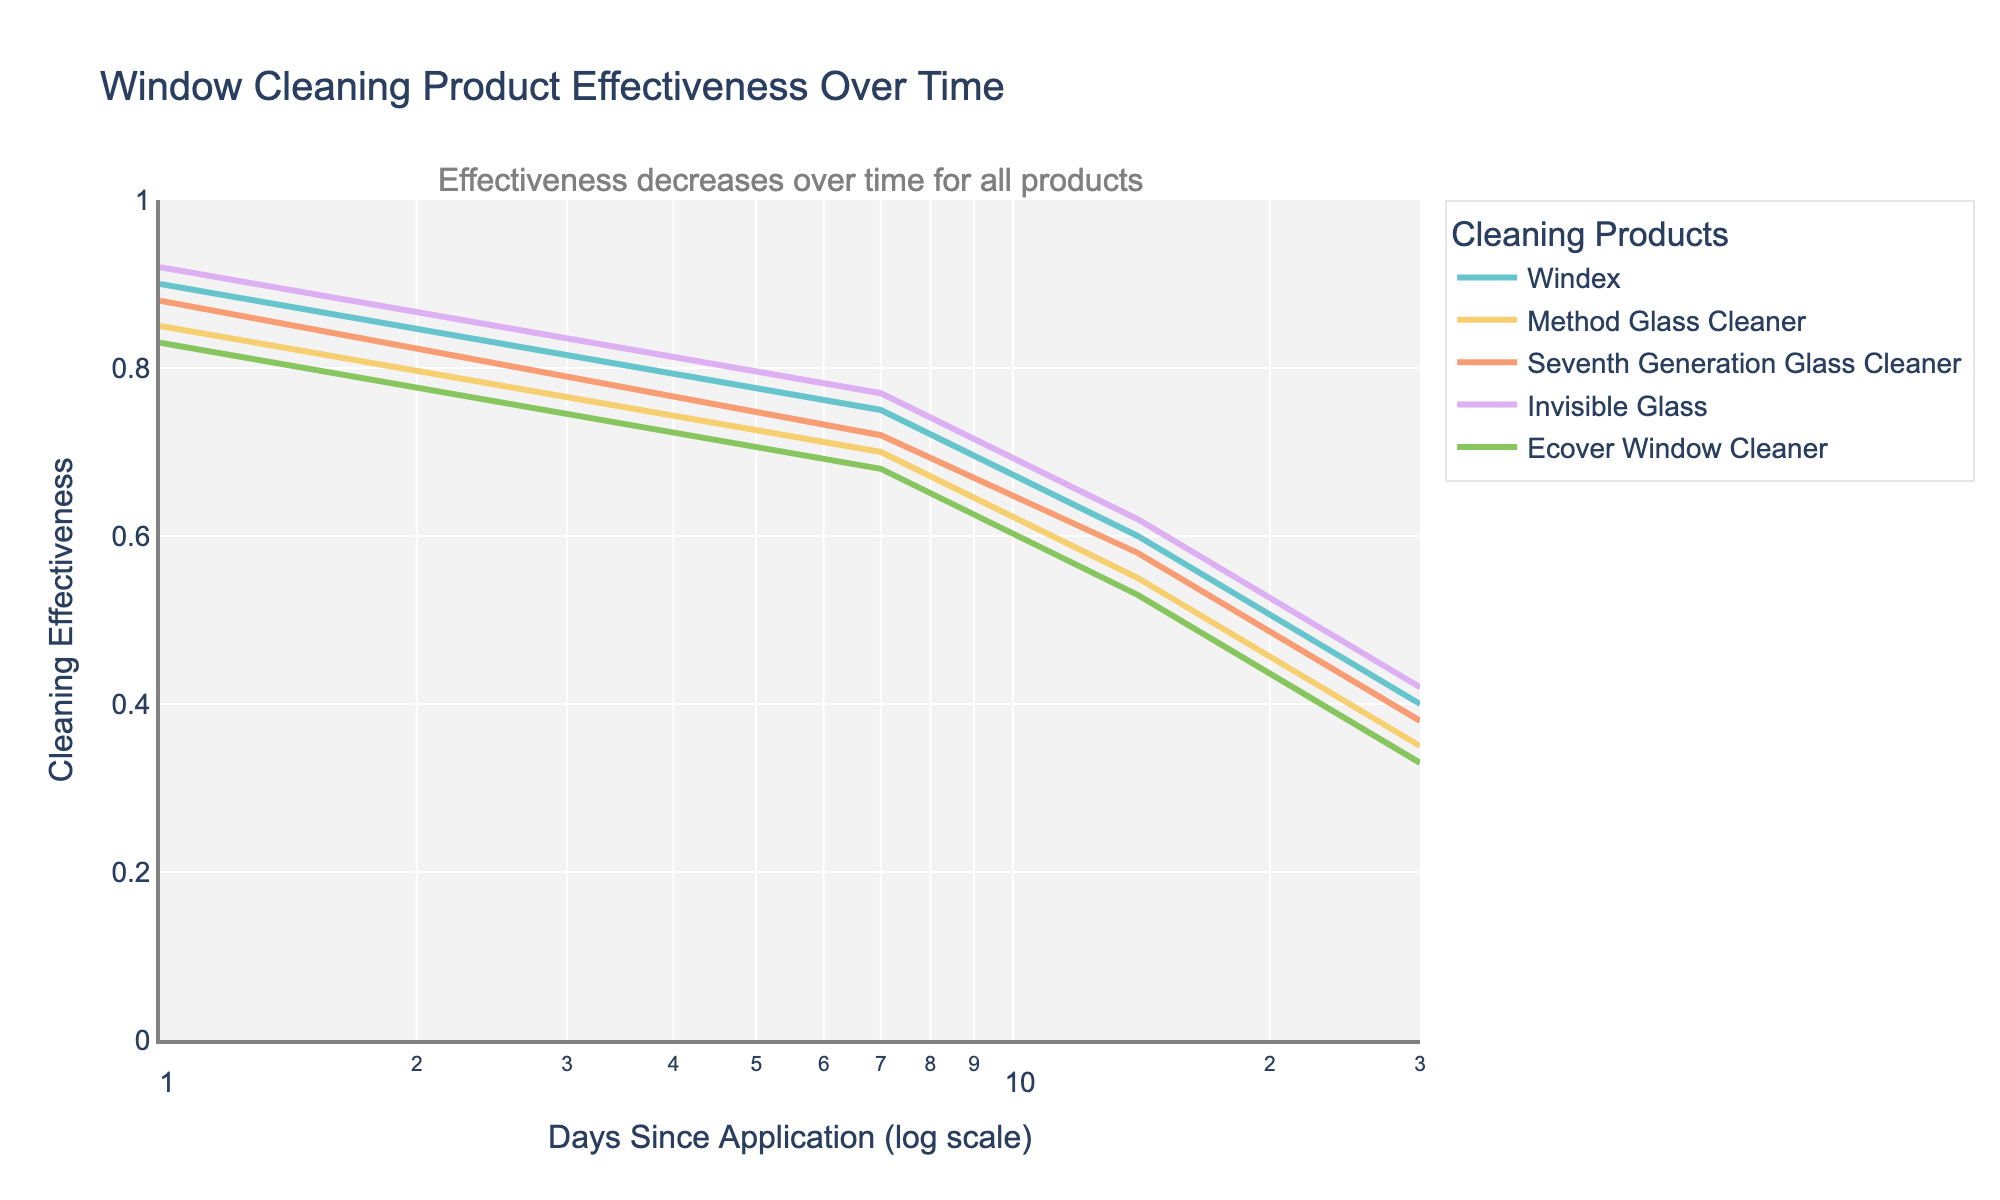Which product starts with the highest effectiveness on day 1? The plot shows that on day 1, Invisible Glass has the highest effectiveness with a value of 0.92. This can be observed by comparing the y-values of all lines at the first point on the x-axis.
Answer: Invisible Glass Which product has the lowest effectiveness after 30 days? On the 30th day, Ecover Window Cleaner has the lowest effectiveness with a value of 0.33. This is determined by looking at the y-values at 30 days for all products and finding the smallest.
Answer: Ecover Window Cleaner What is the overall trend in effectiveness for all products over time? The annotation on the plot confirms that the overall trend is a decrease in effectiveness for all products over time. This can also be observed by the downward slope of all lines on the graph.
Answer: Decreases Which two products have the closest effectiveness on day 14? On day 14, Windex has an effectiveness of 0.6, and Invisible Glass has an effectiveness of 0.62. These values are the closest when comparing all products at the 14-day mark.
Answer: Windex and Invisible Glass How does the effectiveness of Method Glass Cleaner compare to Seventh Generation Glass Cleaner at 7 days? At 7 days, Method Glass Cleaner has an effectiveness of 0.7, while Seventh Generation Glass Cleaner has an effectiveness of 0.72. Seventh Generation Glass Cleaner is slightly more effective than Method Glass Cleaner at this time point.
Answer: Seventh Generation Glass Cleaner is slightly more effective Which product shows the steepest decline in effectiveness from day 1 to day 30? To determine this, we need to calculate the difference in effectiveness from day 1 to day 30 for each product. Ecover Window Cleaner decreases from 0.83 to 0.33, a drop of 0.5. This is the steepest decline among all products.
Answer: Ecover Window Cleaner What is the average effectiveness of all products on day 1? Calculate the average of effectiveness for all products on day 1: (0.9 + 0.85 + 0.88 + 0.92 + 0.83) / 5 = 0.876.
Answer: 0.876 Which product maintains above 0.5 effectiveness the longest? By observing at what point each product's effectiveness drops below 0.5, Invisible Glass maintains above 0.5 effectiveness the longest, until after 14 days.
Answer: Invisible Glass 